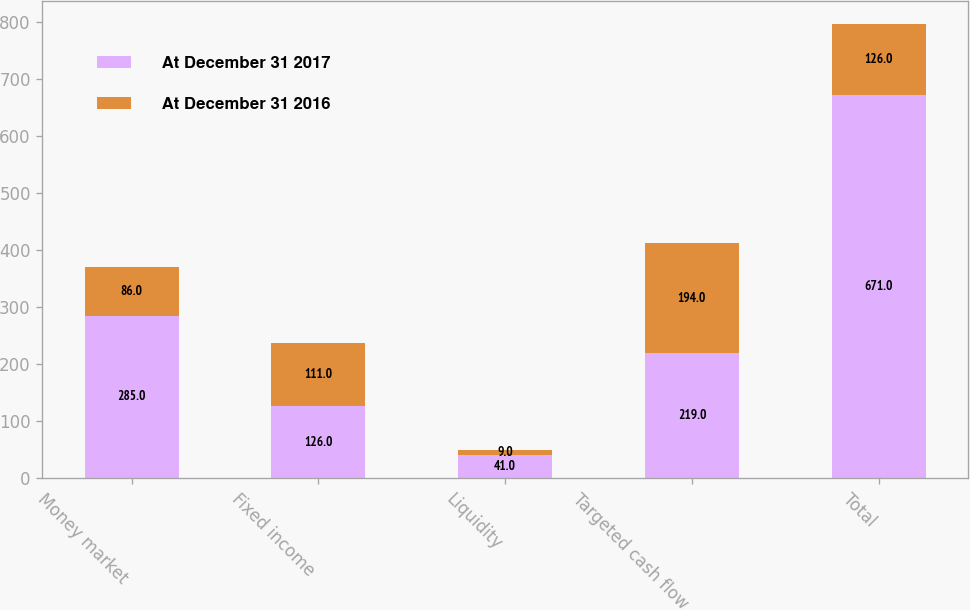Convert chart. <chart><loc_0><loc_0><loc_500><loc_500><stacked_bar_chart><ecel><fcel>Money market<fcel>Fixed income<fcel>Liquidity<fcel>Targeted cash flow<fcel>Total<nl><fcel>At December 31 2017<fcel>285<fcel>126<fcel>41<fcel>219<fcel>671<nl><fcel>At December 31 2016<fcel>86<fcel>111<fcel>9<fcel>194<fcel>126<nl></chart> 